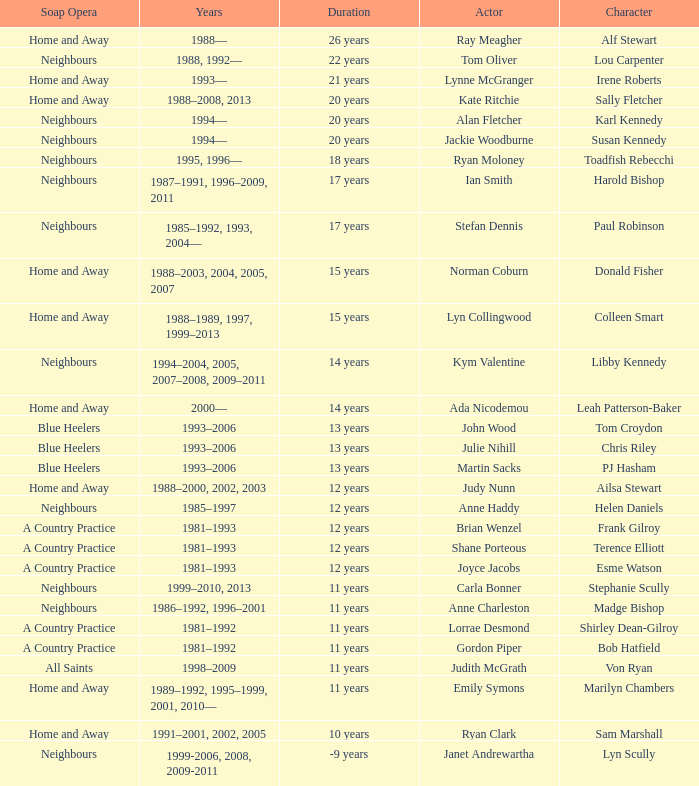Which actor played Harold Bishop for 17 years? Ian Smith. 